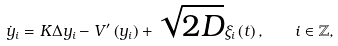Convert formula to latex. <formula><loc_0><loc_0><loc_500><loc_500>\dot { y } _ { i } = K \Delta y _ { i } - V ^ { \prime } \left ( { y _ { i } } \right ) + \sqrt { 2 D } \xi _ { i } \left ( t \right ) , \quad i \in \mathbb { Z } ,</formula> 